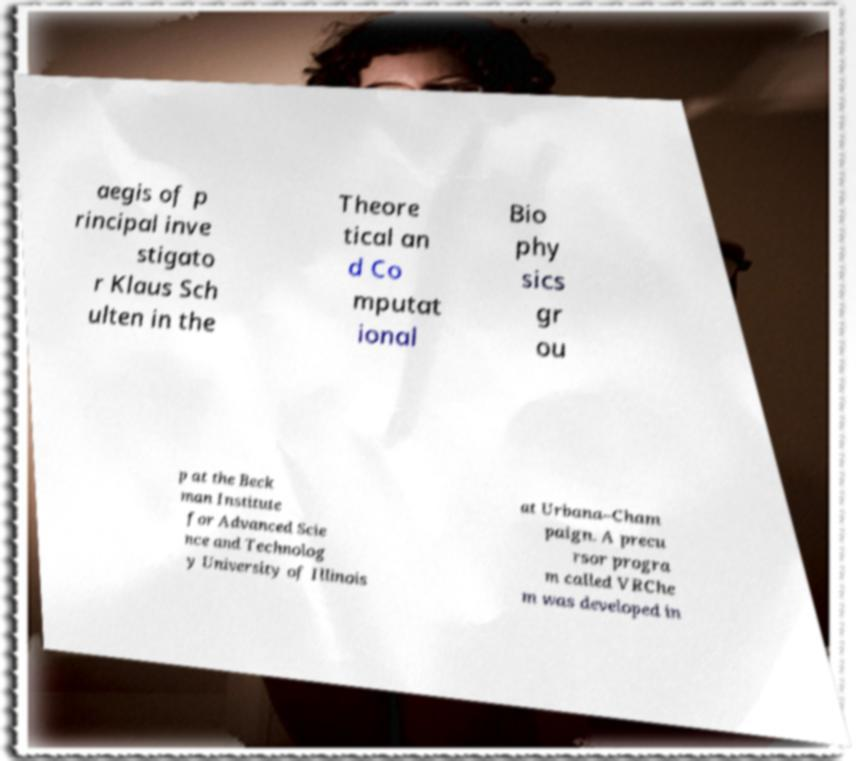What messages or text are displayed in this image? I need them in a readable, typed format. aegis of p rincipal inve stigato r Klaus Sch ulten in the Theore tical an d Co mputat ional Bio phy sics gr ou p at the Beck man Institute for Advanced Scie nce and Technolog y University of Illinois at Urbana–Cham paign. A precu rsor progra m called VRChe m was developed in 